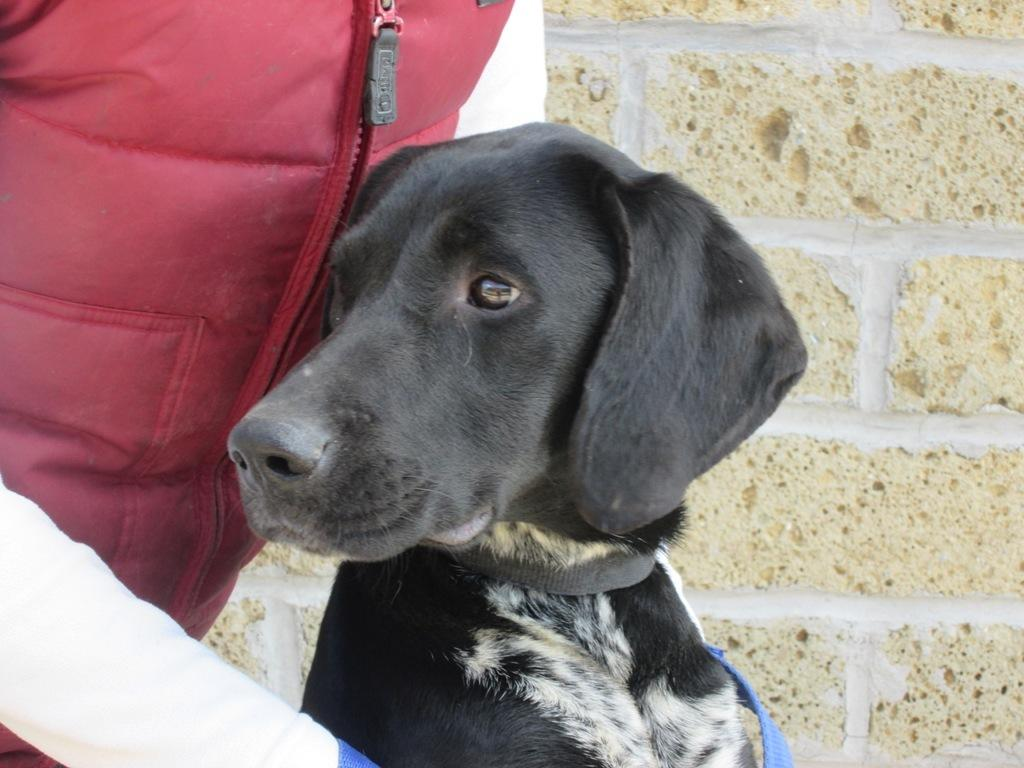What is located in the center of the image? There is a person and a dog in the center of the image. Can you describe the relationship between the person and the dog in the image? The facts provided do not give enough information to determine the relationship between the person and the dog. What can be seen in the background of the image? There is a wall in the background of the image. What is the title of the scene depicted in the image? There is no scene depicted in the image, as it is a photograph of a person and a dog in the center of the frame. 